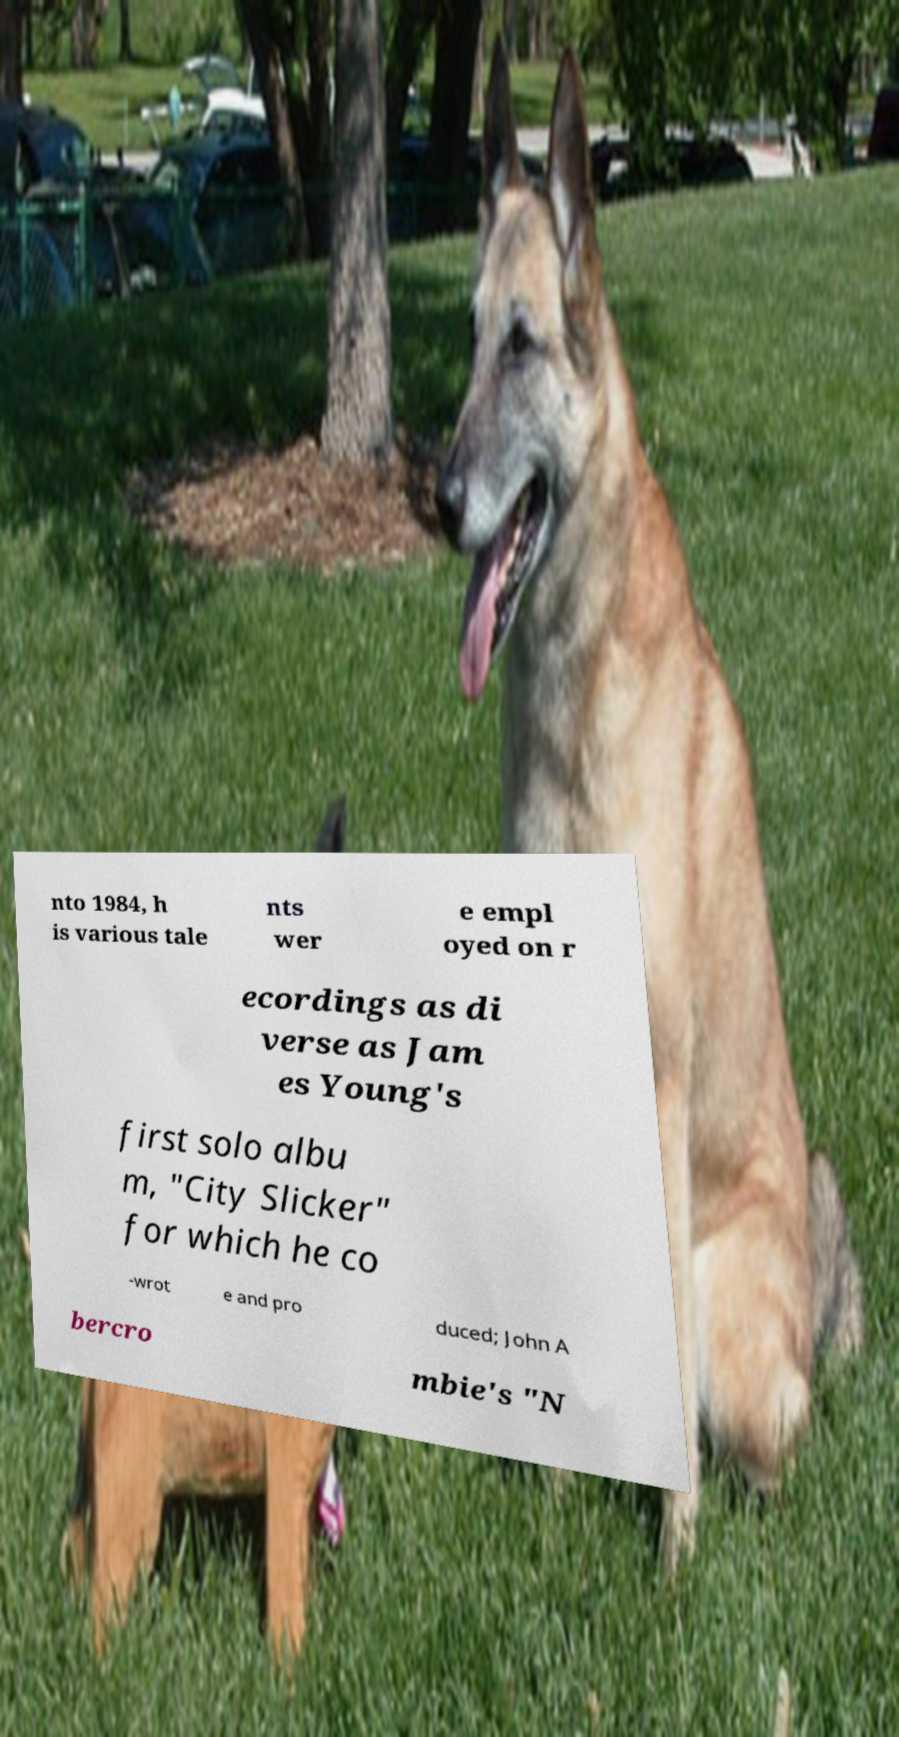Could you extract and type out the text from this image? nto 1984, h is various tale nts wer e empl oyed on r ecordings as di verse as Jam es Young's first solo albu m, "City Slicker" for which he co -wrot e and pro duced; John A bercro mbie's "N 